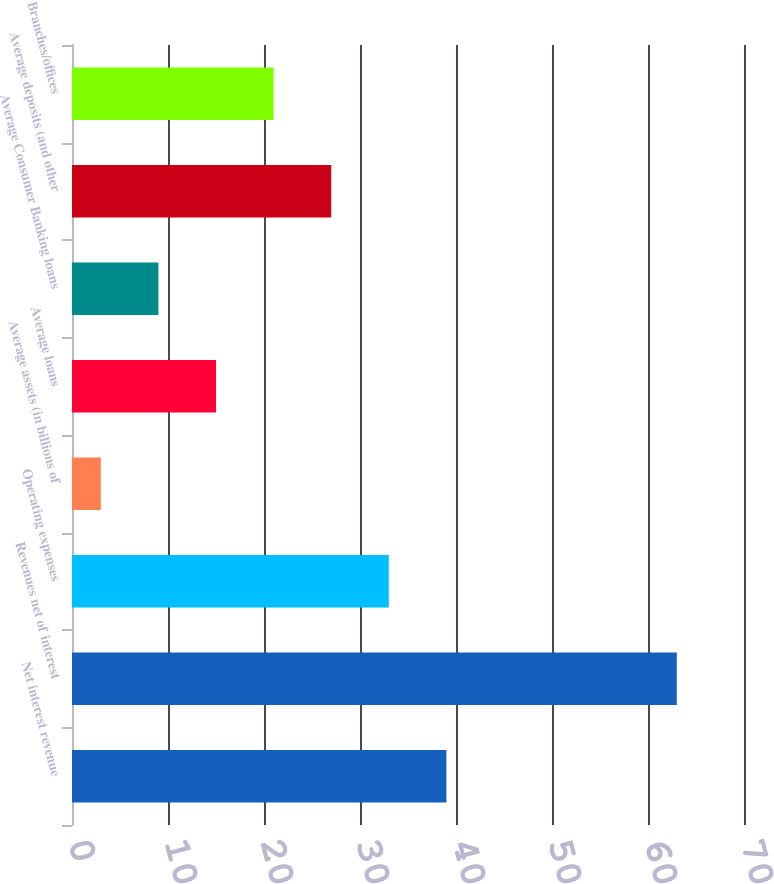Convert chart to OTSL. <chart><loc_0><loc_0><loc_500><loc_500><bar_chart><fcel>Net interest revenue<fcel>Revenues net of interest<fcel>Operating expenses<fcel>Average assets (in billions of<fcel>Average loans<fcel>Average Consumer Banking loans<fcel>Average deposits (and other<fcel>Branches/offices<nl><fcel>39<fcel>63<fcel>33<fcel>3<fcel>15<fcel>9<fcel>27<fcel>21<nl></chart> 